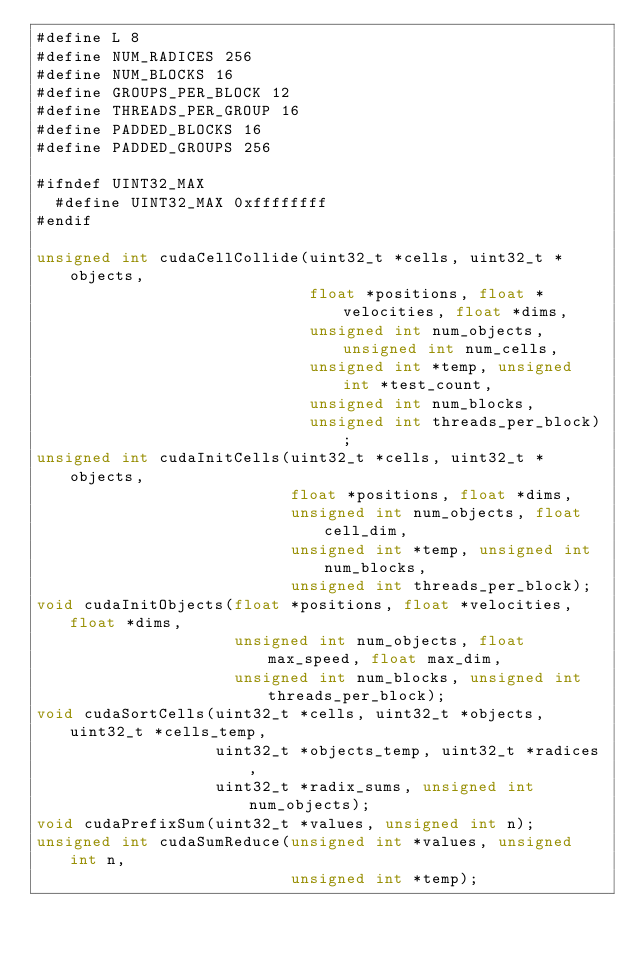Convert code to text. <code><loc_0><loc_0><loc_500><loc_500><_Cuda_>#define L 8
#define NUM_RADICES 256
#define NUM_BLOCKS 16
#define GROUPS_PER_BLOCK 12
#define THREADS_PER_GROUP 16
#define PADDED_BLOCKS 16
#define PADDED_GROUPS 256

#ifndef UINT32_MAX
  #define UINT32_MAX 0xffffffff
#endif

unsigned int cudaCellCollide(uint32_t *cells, uint32_t *objects,
                             float *positions, float *velocities, float *dims,
                             unsigned int num_objects, unsigned int num_cells,
                             unsigned int *temp, unsigned int *test_count,
                             unsigned int num_blocks,
                             unsigned int threads_per_block);
unsigned int cudaInitCells(uint32_t *cells, uint32_t *objects,
                           float *positions, float *dims,
                           unsigned int num_objects, float cell_dim,
                           unsigned int *temp, unsigned int num_blocks,
                           unsigned int threads_per_block);
void cudaInitObjects(float *positions, float *velocities, float *dims,
                     unsigned int num_objects, float max_speed, float max_dim,
                     unsigned int num_blocks, unsigned int threads_per_block);
void cudaSortCells(uint32_t *cells, uint32_t *objects, uint32_t *cells_temp,
                   uint32_t *objects_temp, uint32_t *radices,
                   uint32_t *radix_sums, unsigned int num_objects);
void cudaPrefixSum(uint32_t *values, unsigned int n);
unsigned int cudaSumReduce(unsigned int *values, unsigned int n,
                           unsigned int *temp);
</code> 